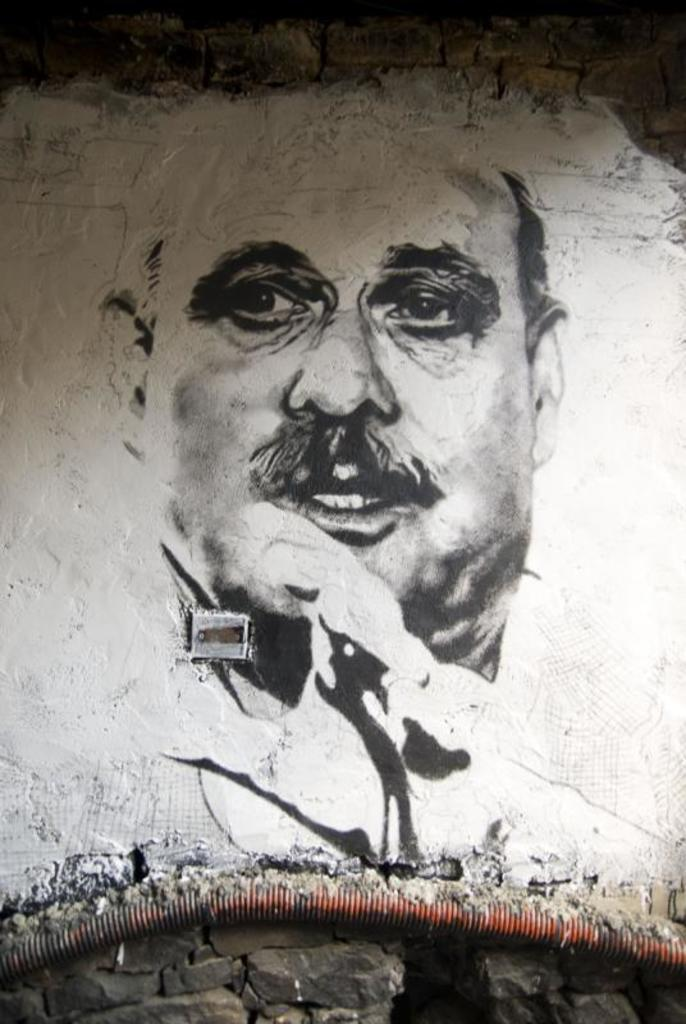What is the main subject in the center of the image? There is a sketch on a wall in the center of the image. Can you describe any other elements in the image? There is a pipe at the bottom side of the image. How many oranges are hanging from the pipe in the image? There are no oranges present in the image; the pipe is the only element mentioned in the facts. 